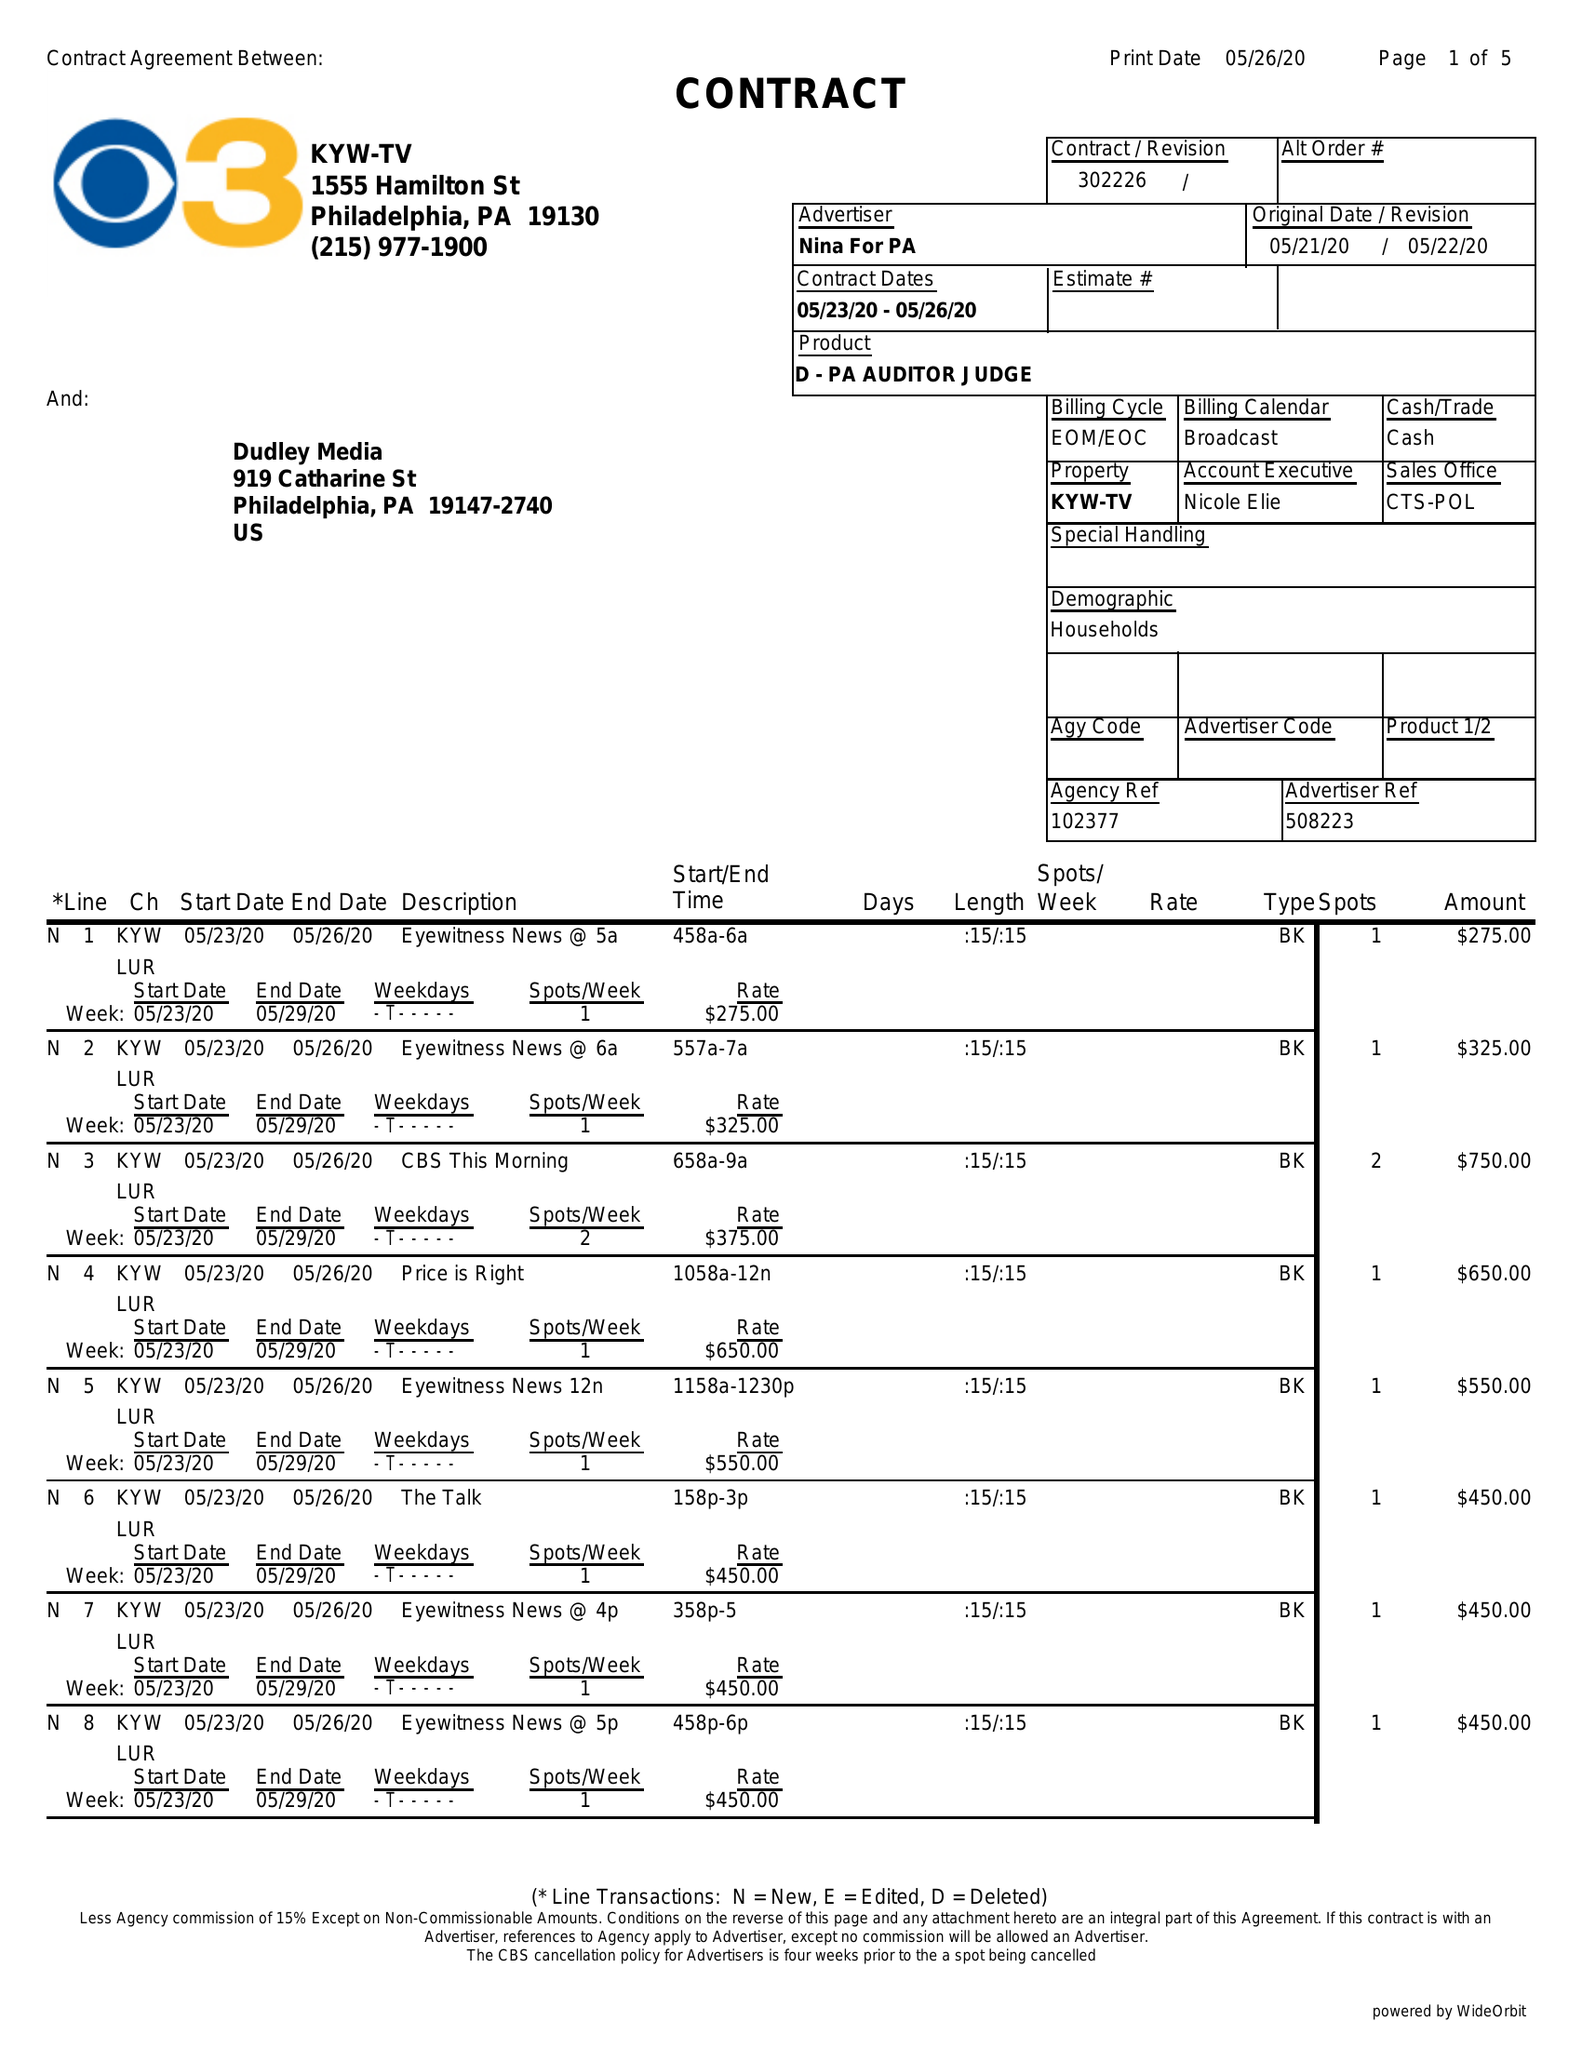What is the value for the gross_amount?
Answer the question using a single word or phrase. 8650.00 